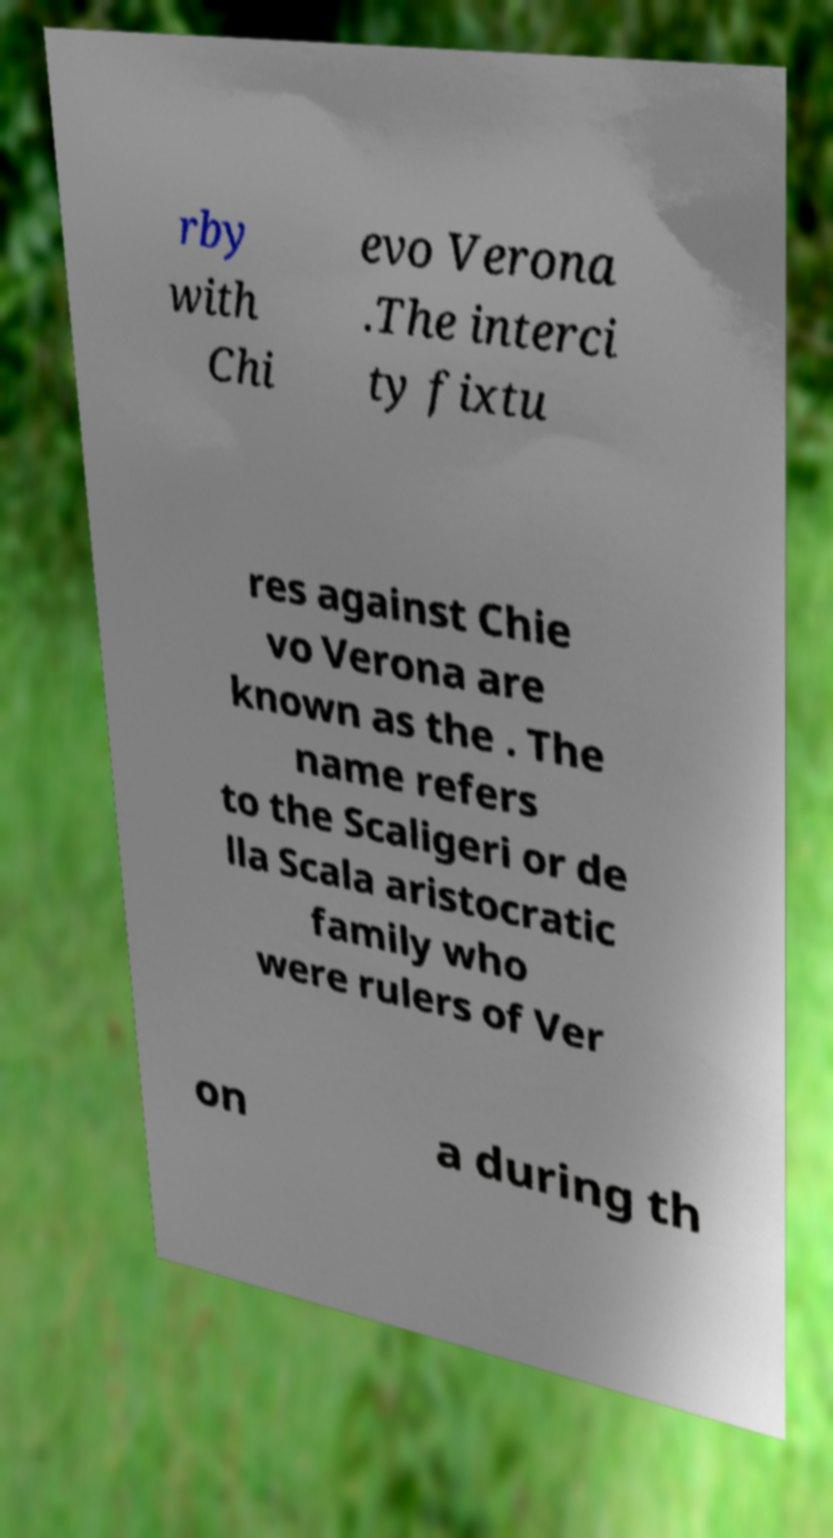Could you assist in decoding the text presented in this image and type it out clearly? rby with Chi evo Verona .The interci ty fixtu res against Chie vo Verona are known as the . The name refers to the Scaligeri or de lla Scala aristocratic family who were rulers of Ver on a during th 